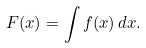Convert formula to latex. <formula><loc_0><loc_0><loc_500><loc_500>F ( x ) = \int f ( x ) \, d x .</formula> 